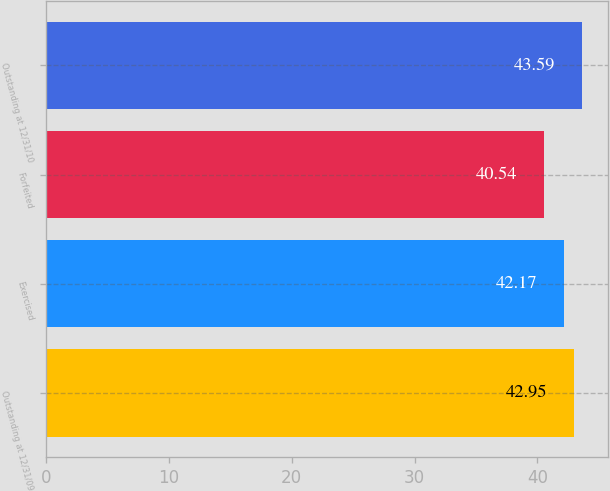<chart> <loc_0><loc_0><loc_500><loc_500><bar_chart><fcel>Outstanding at 12/31/09<fcel>Exercised<fcel>Forfeited<fcel>Outstanding at 12/31/10<nl><fcel>42.95<fcel>42.17<fcel>40.54<fcel>43.59<nl></chart> 